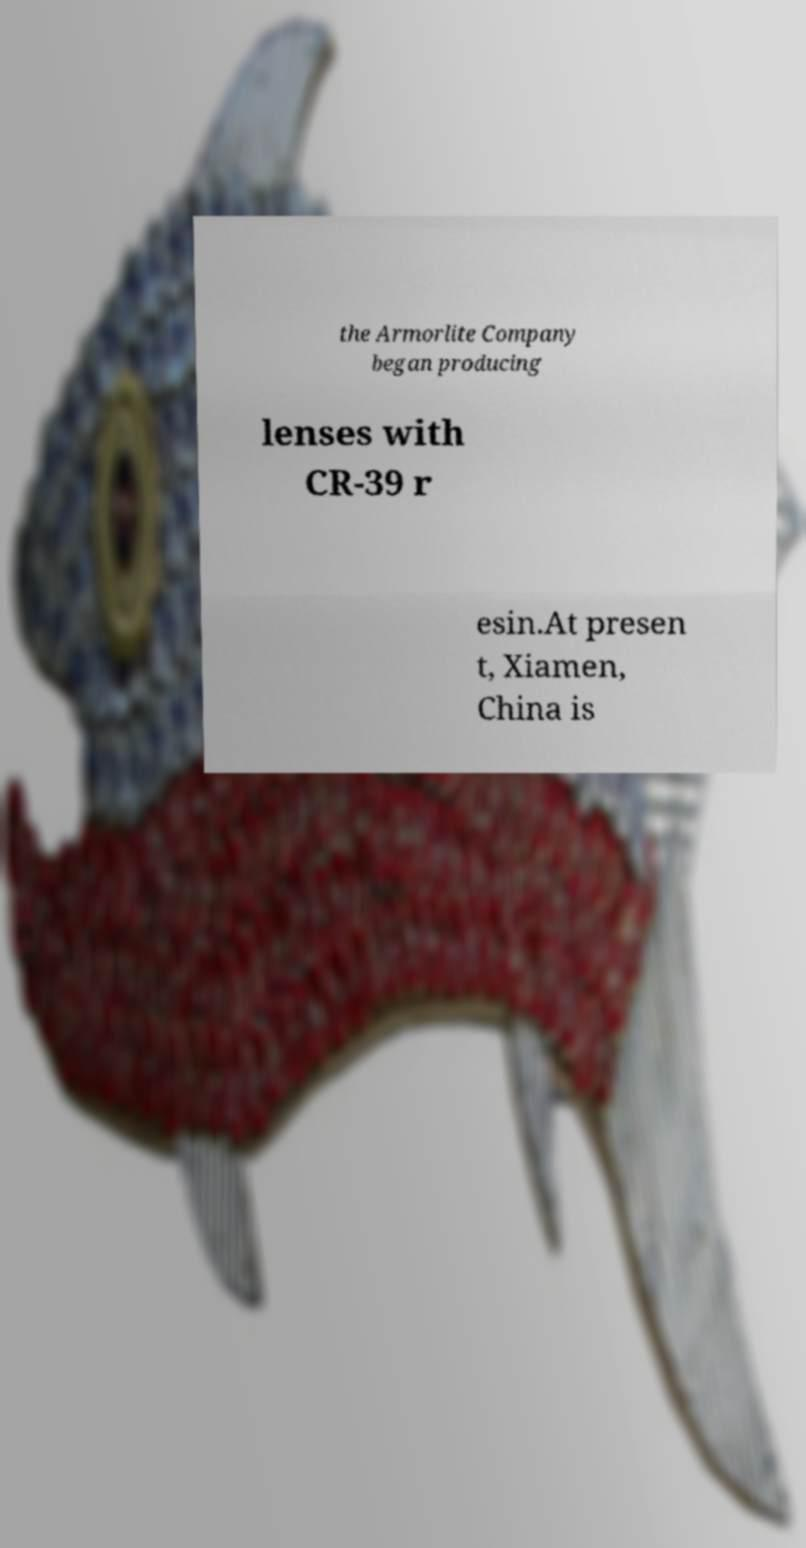Can you accurately transcribe the text from the provided image for me? the Armorlite Company began producing lenses with CR-39 r esin.At presen t, Xiamen, China is 